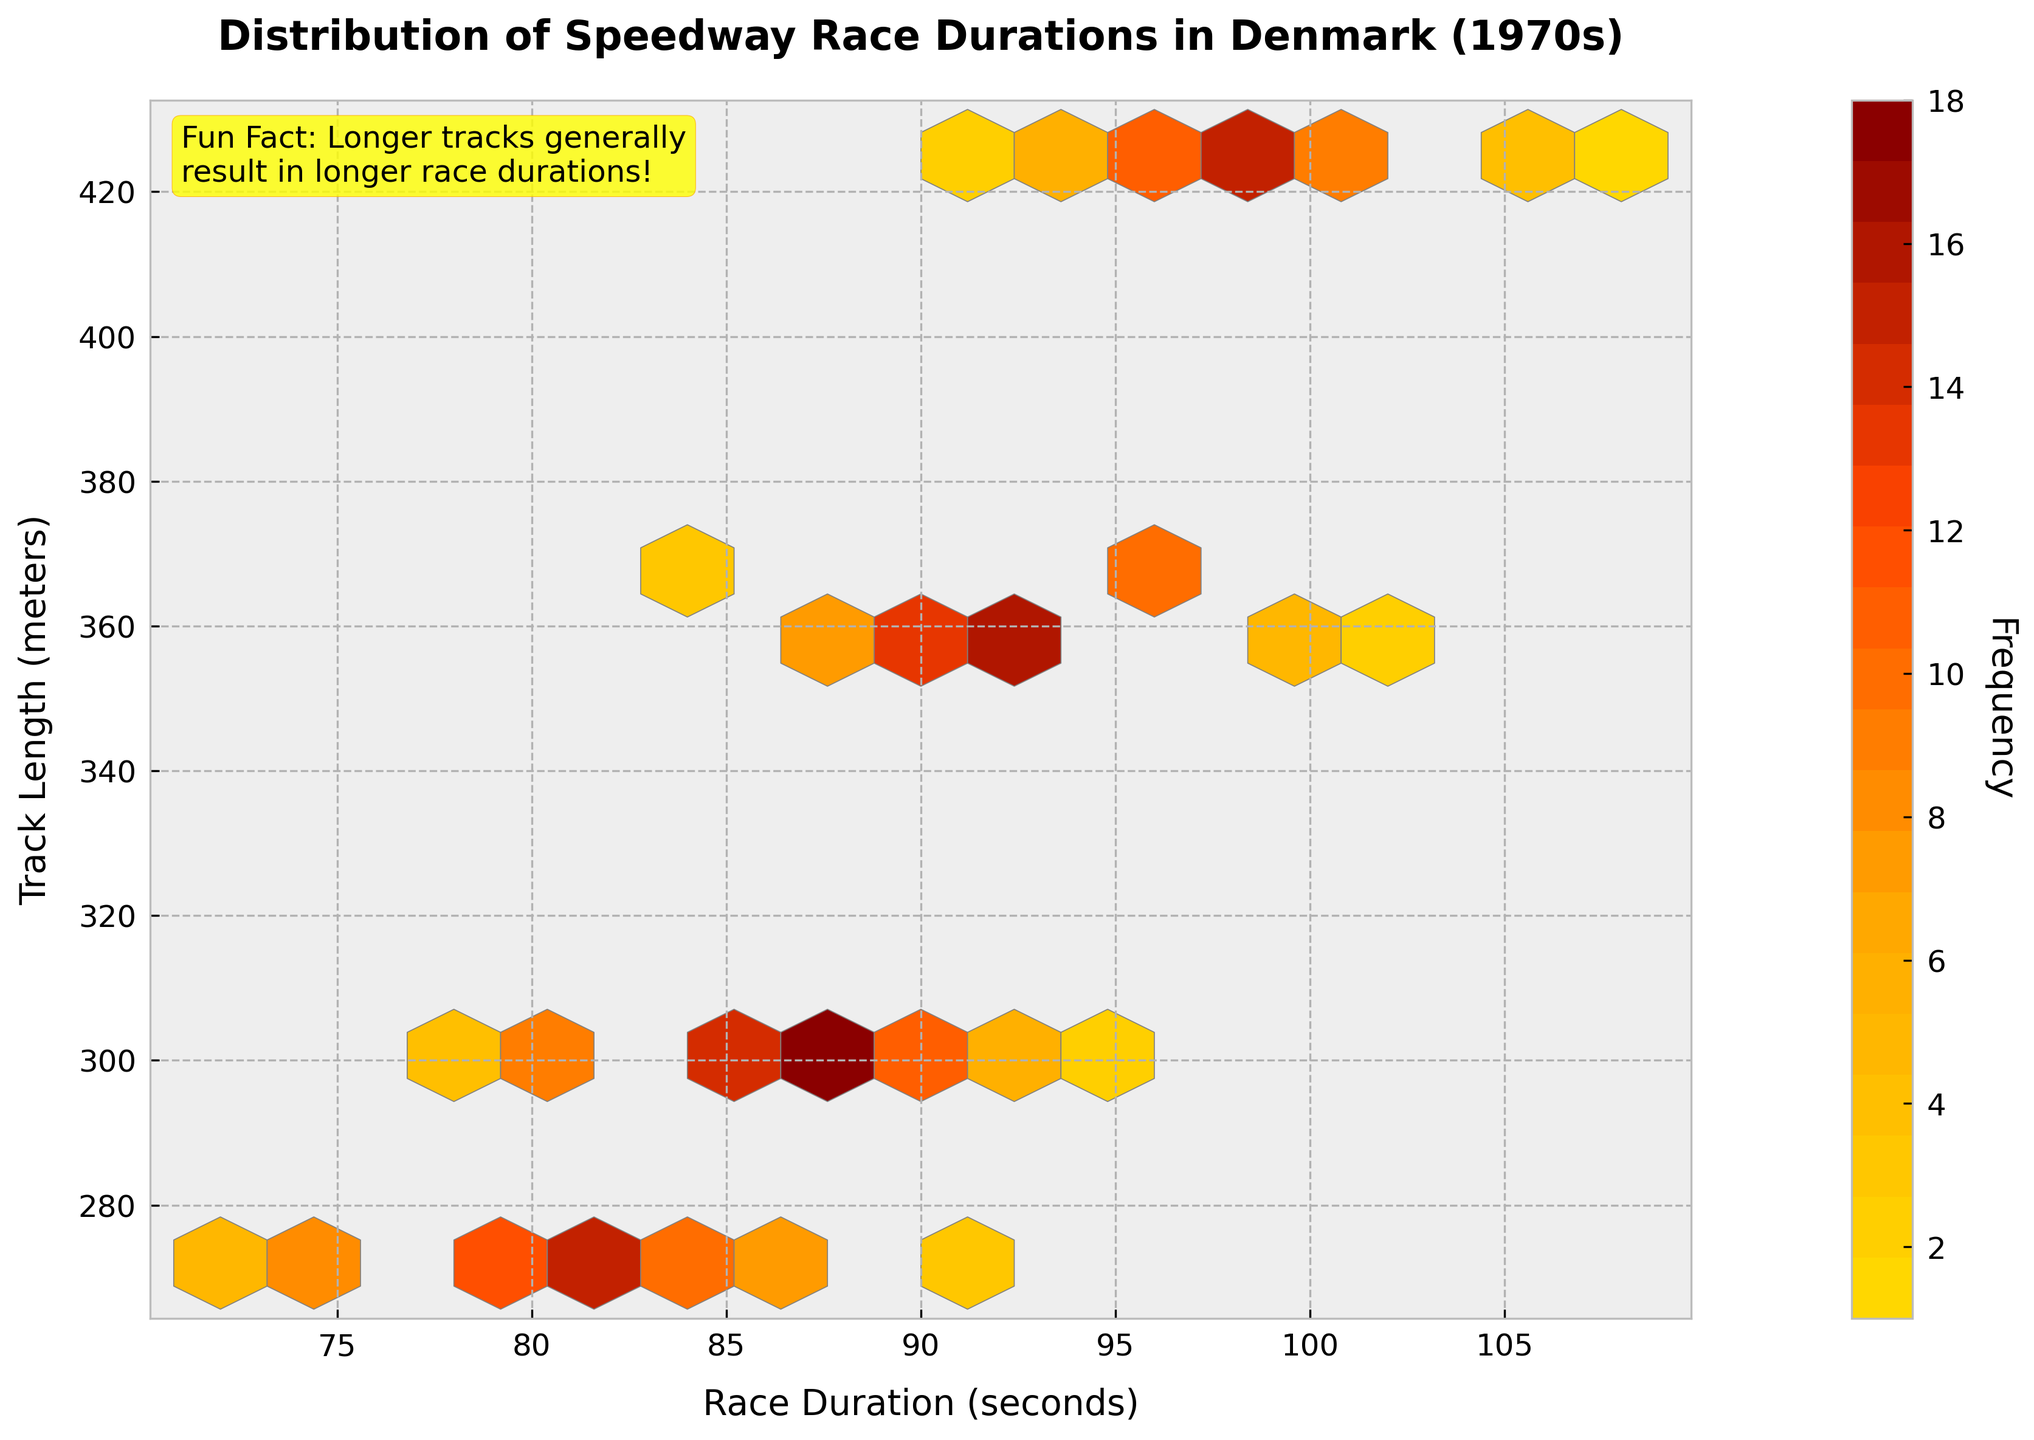What is the title of the plot? The title is located at the top of the plot, providing a summary of the data being visualized. It states the main context of the figure, which is the distribution of speedway race durations in Denmark during the 1970s.
Answer: Distribution of Speedway Race Durations in Denmark (1970s) What are the axes labels of the plot? The labels of the axes describe the data being represented on each axis. The x-axis represents "Race Duration (seconds)", and the y-axis represents "Track Length (meters)".
Answer: x-axis: Race Duration (seconds), y-axis: Track Length (meters) How is the frequency of race durations visually indicated in the plot? The frequency of race durations is shown using a color scale. The hexbin plot uses colors ranging from yellow to dark red to indicate low to high frequencies, respectively.
Answer: Color scale Which track length has the highest race duration frequency around 87 seconds? To find this, locate 87 seconds on the x-axis and observe the color intensity along a vertical section at this point. The track length with highest frequency will have the darkest shade along this section.
Answer: 302 meters Which track length ranges are covered in the figure and how do their race durations differ? Track lengths of 272, 302, 362, and 425 meters are covered. Longer tracks generally have longer race durations. To observe this, follow the color gradient trend from left (shorter durations) to right (longer durations) for each track length.
Answer: 272, 302, 362, 425 meters; Longer tracks have longer durations What is the overall trend in race duration as track length increases? The overall trend is derived by observing the direction of increasing color intensity. Typically, as the track length (y-axis) increases, the race duration (x-axis) also increases, shown by the position of colored hexagons shifting rightward.
Answer: Race durations increase with track length What is the most common race duration for a 362-meter track? The most common race duration is found by identifying the darkest hexagon along the 362-meter mark on the y-axis. The corresponding x-axis value indicates the duration.
Answer: 93 seconds Compare the race duration distributions between the 272 meters and 425 meters tracks. What do you observe? To compare, examine the hexbin shades from the bottom y-axis (272 meters) to the top (425 meters). 272 meters has lighter shades clustered around shorter durations (72-90 seconds), while 425 meters has darker shades and longer durations (90-108 seconds).
Answer: 272 meters: shorter durations; 425 meters: longer durations Is there any unique observation about the distribution of race durations on the longest track? Unique observations include the range and frequency of durations. The 425-meter track has a more spread out duration distribution from 90 to 108 seconds, with darker shades (indicative of higher frequencies) appearing around 96-99 seconds.
Answer: Duration span is 90-108 seconds, higher frequency around 96-99 seconds 